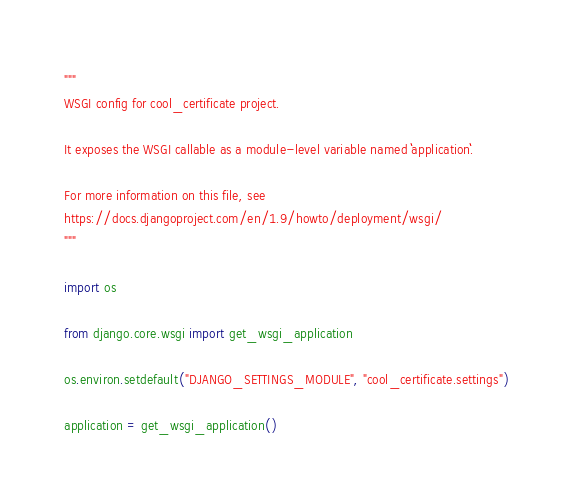<code> <loc_0><loc_0><loc_500><loc_500><_Python_>"""
WSGI config for cool_certificate project.

It exposes the WSGI callable as a module-level variable named ``application``.

For more information on this file, see
https://docs.djangoproject.com/en/1.9/howto/deployment/wsgi/
"""

import os

from django.core.wsgi import get_wsgi_application

os.environ.setdefault("DJANGO_SETTINGS_MODULE", "cool_certificate.settings")

application = get_wsgi_application()
</code> 